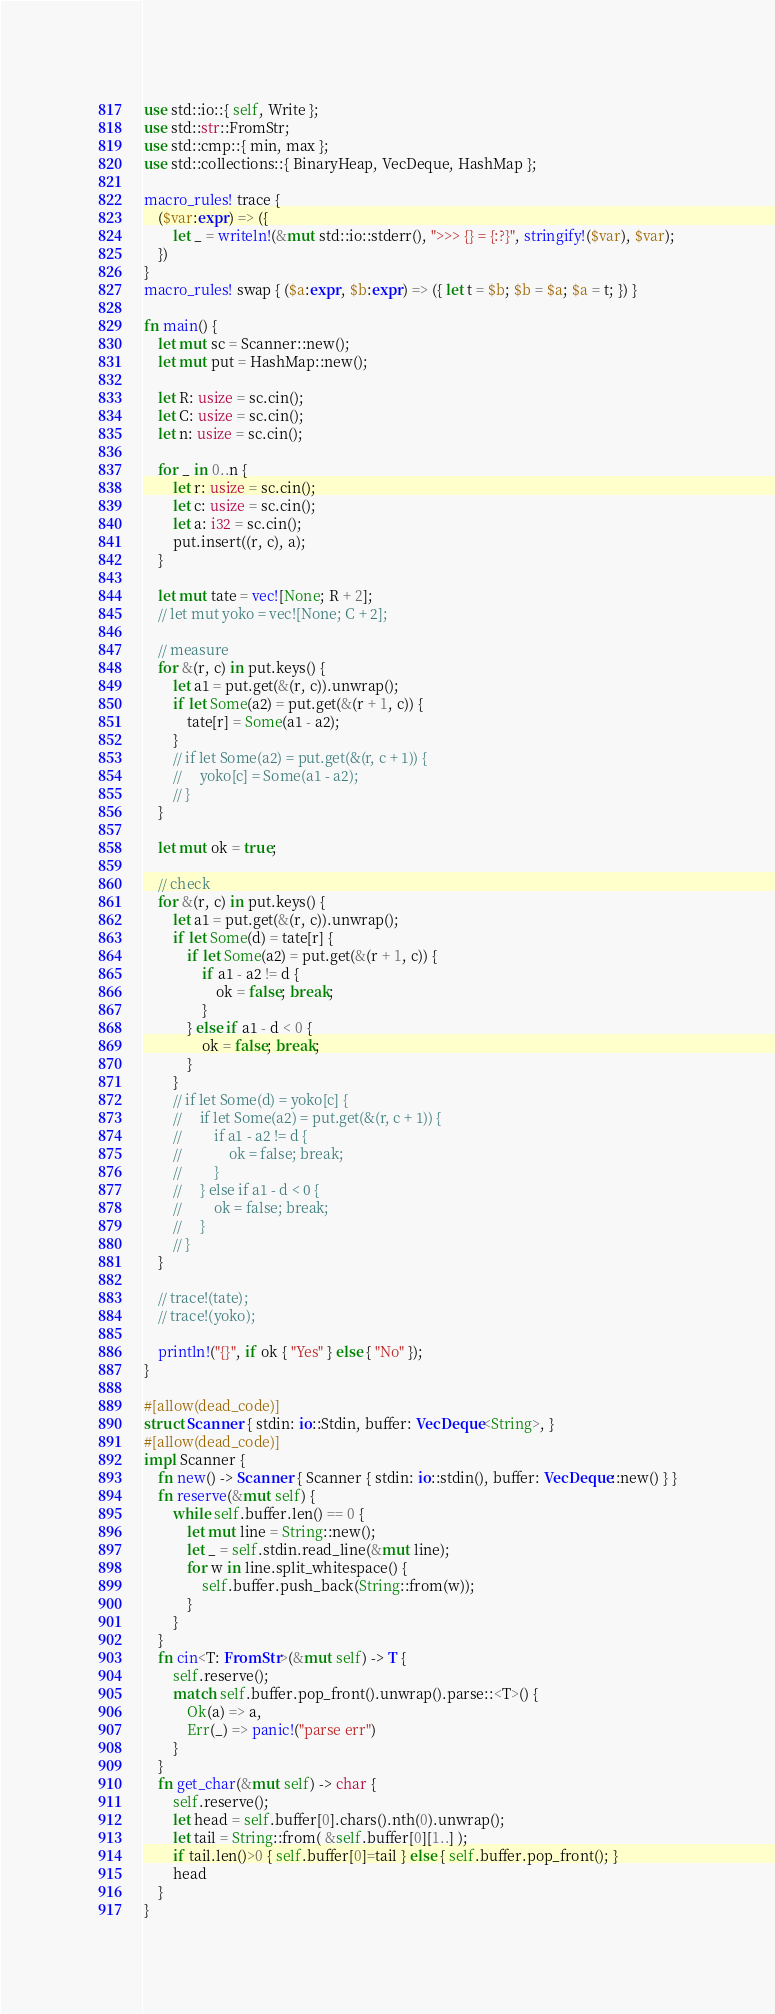<code> <loc_0><loc_0><loc_500><loc_500><_Rust_>use std::io::{ self, Write };
use std::str::FromStr;
use std::cmp::{ min, max };
use std::collections::{ BinaryHeap, VecDeque, HashMap };

macro_rules! trace {
    ($var:expr) => ({
        let _ = writeln!(&mut std::io::stderr(), ">>> {} = {:?}", stringify!($var), $var);
    })
}
macro_rules! swap { ($a:expr, $b:expr) => ({ let t = $b; $b = $a; $a = t; }) }

fn main() {
    let mut sc = Scanner::new();
    let mut put = HashMap::new();

    let R: usize = sc.cin();
    let C: usize = sc.cin();
    let n: usize = sc.cin();

    for _ in 0..n {
        let r: usize = sc.cin();
        let c: usize = sc.cin();
        let a: i32 = sc.cin();
        put.insert((r, c), a);
    }

    let mut tate = vec![None; R + 2];
    // let mut yoko = vec![None; C + 2];

    // measure
    for &(r, c) in put.keys() {
        let a1 = put.get(&(r, c)).unwrap();
        if let Some(a2) = put.get(&(r + 1, c)) {
            tate[r] = Some(a1 - a2);
        }
        // if let Some(a2) = put.get(&(r, c + 1)) {
        //     yoko[c] = Some(a1 - a2);
        // }
    }

    let mut ok = true;

    // check
    for &(r, c) in put.keys() {
        let a1 = put.get(&(r, c)).unwrap();
        if let Some(d) = tate[r] {
            if let Some(a2) = put.get(&(r + 1, c)) {
                if a1 - a2 != d {
                    ok = false; break;
                }
            } else if a1 - d < 0 {
                ok = false; break;
            }
        }
        // if let Some(d) = yoko[c] {
        //     if let Some(a2) = put.get(&(r, c + 1)) {
        //         if a1 - a2 != d {
        //             ok = false; break;
        //         }
        //     } else if a1 - d < 0 {
        //         ok = false; break;
        //     }
        // }
    }

    // trace!(tate);
    // trace!(yoko);

    println!("{}", if ok { "Yes" } else { "No" });
}

#[allow(dead_code)]
struct Scanner { stdin: io::Stdin, buffer: VecDeque<String>, }
#[allow(dead_code)]
impl Scanner {
    fn new() -> Scanner { Scanner { stdin: io::stdin(), buffer: VecDeque::new() } }
    fn reserve(&mut self) {
        while self.buffer.len() == 0 {
            let mut line = String::new();
            let _ = self.stdin.read_line(&mut line);
            for w in line.split_whitespace() {
                self.buffer.push_back(String::from(w));
            }
        }
    }
    fn cin<T: FromStr>(&mut self) -> T {
        self.reserve();
        match self.buffer.pop_front().unwrap().parse::<T>() {
            Ok(a) => a,
            Err(_) => panic!("parse err")
        }
    }
    fn get_char(&mut self) -> char {
        self.reserve();
        let head = self.buffer[0].chars().nth(0).unwrap();
        let tail = String::from( &self.buffer[0][1..] );
        if tail.len()>0 { self.buffer[0]=tail } else { self.buffer.pop_front(); }
        head
    }
}
</code> 